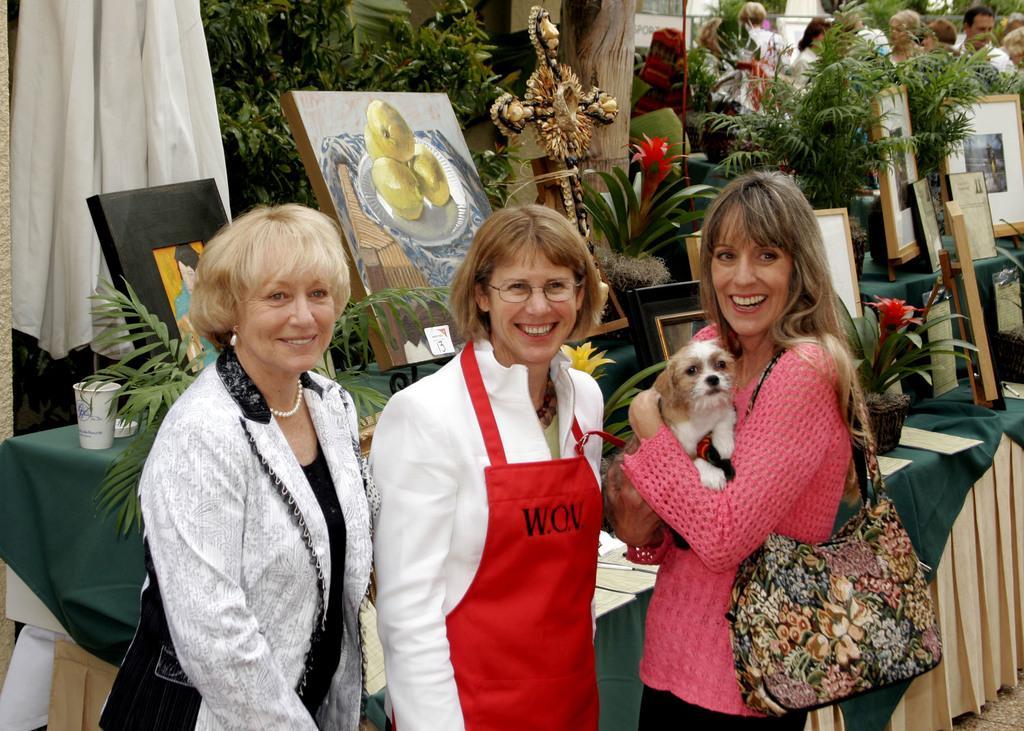Could you give a brief overview of what you see in this image? In this image there are three women standing in the front and facing the camera. This image is clicked outside. To the right, the women wearing pink shirt, is holding a dog. In the middle the woman is wearing a red apron. In the background there are paintings, photo frames, and trees and a white cloth to the left top. 